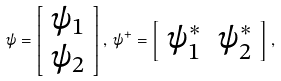<formula> <loc_0><loc_0><loc_500><loc_500>\psi = \left [ \begin{array} { c } \psi _ { 1 } \\ \psi _ { 2 } \end{array} \right ] , \, \psi ^ { + } = \left [ \begin{array} { c c } \psi _ { 1 } ^ { * } & \psi _ { 2 } ^ { * } \end{array} \right ] , \,</formula> 